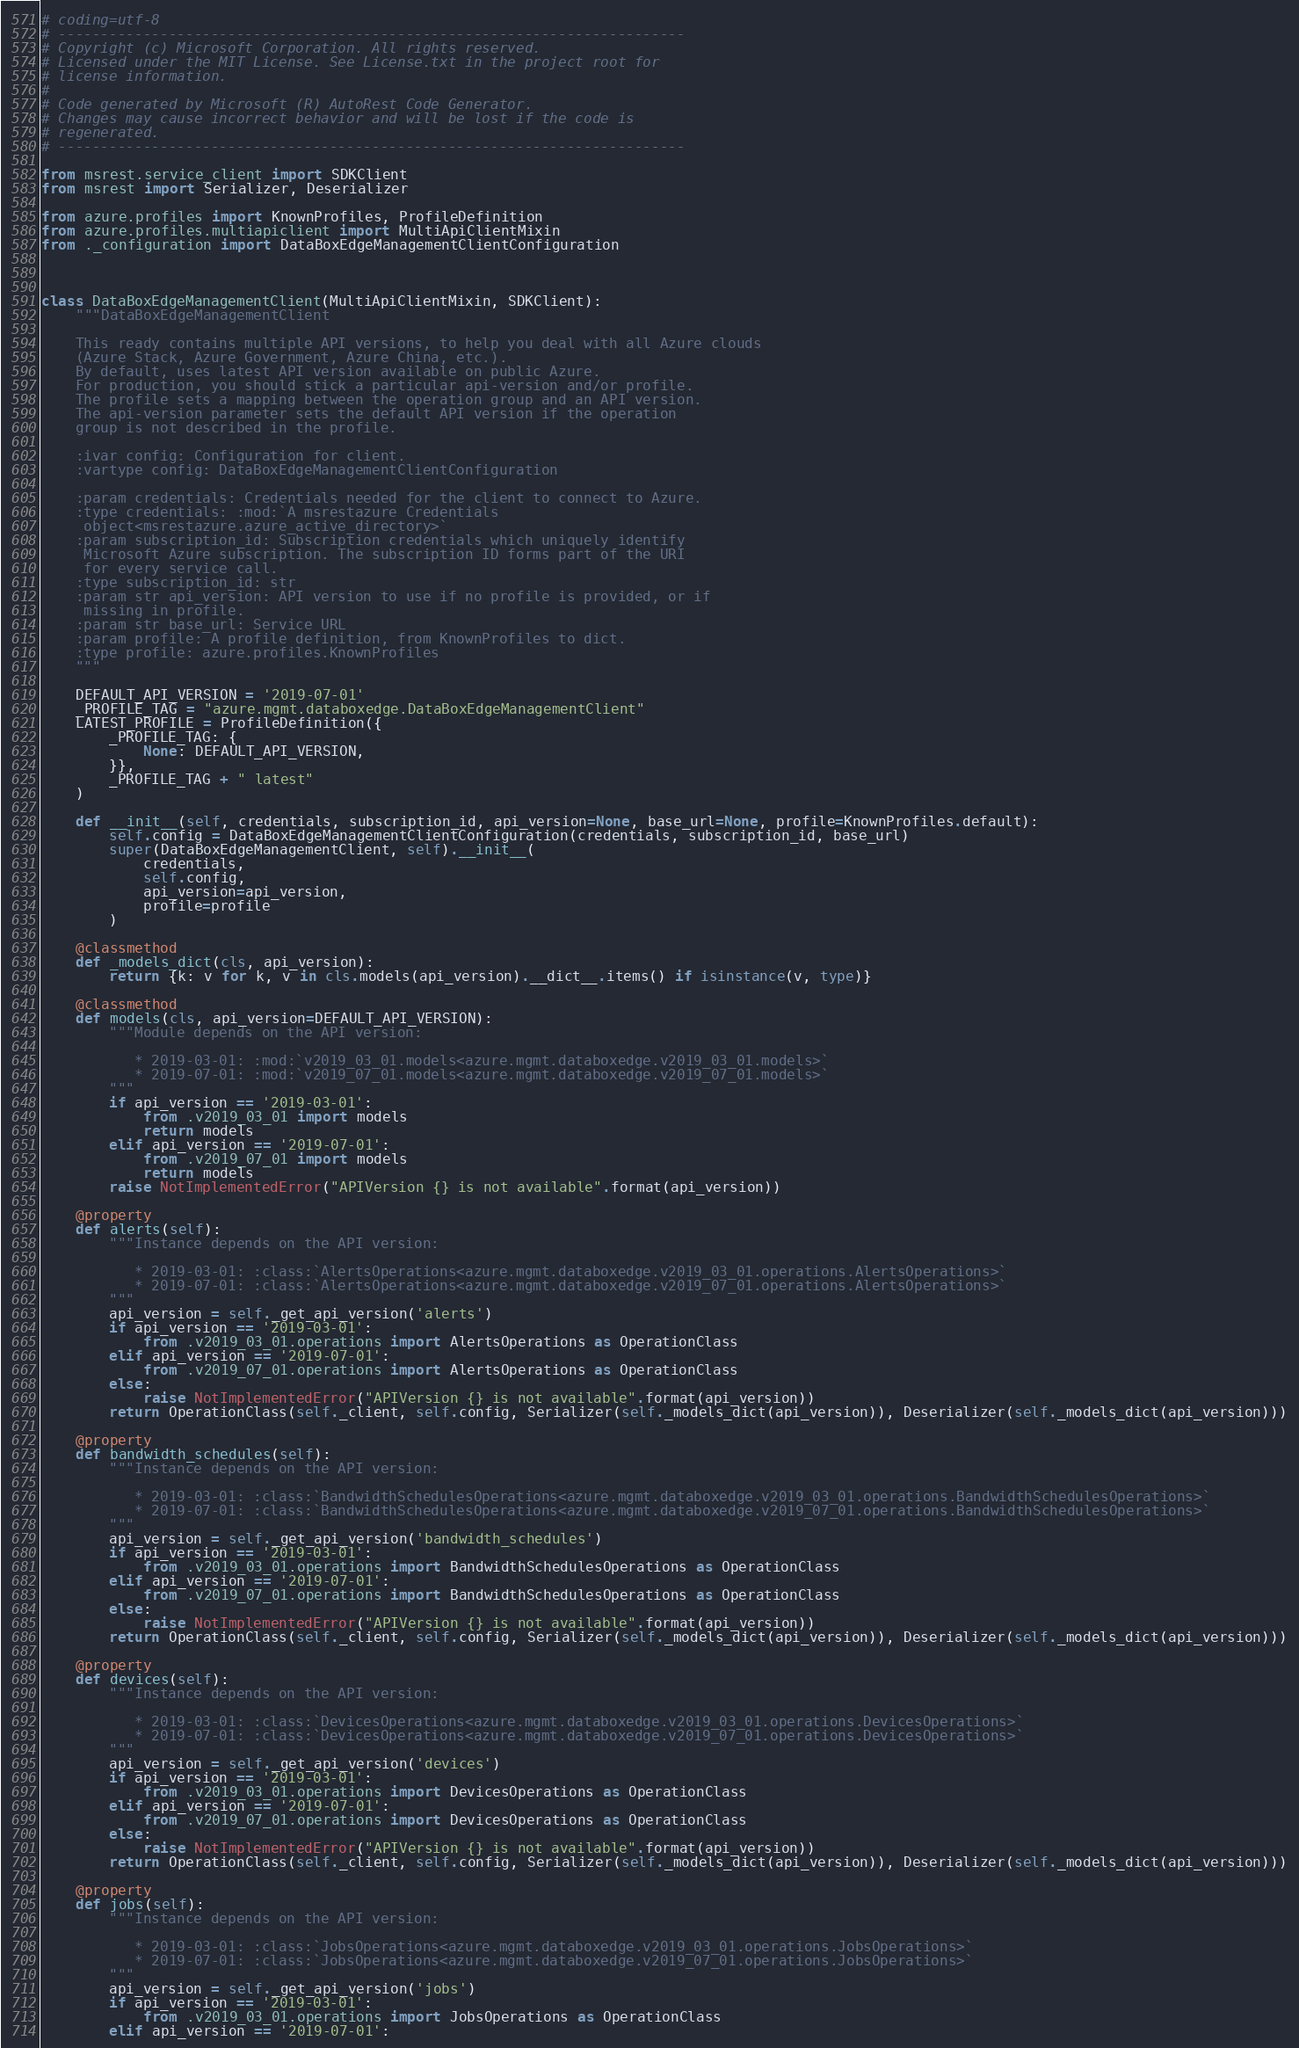<code> <loc_0><loc_0><loc_500><loc_500><_Python_># coding=utf-8
# --------------------------------------------------------------------------
# Copyright (c) Microsoft Corporation. All rights reserved.
# Licensed under the MIT License. See License.txt in the project root for
# license information.
#
# Code generated by Microsoft (R) AutoRest Code Generator.
# Changes may cause incorrect behavior and will be lost if the code is
# regenerated.
# --------------------------------------------------------------------------

from msrest.service_client import SDKClient
from msrest import Serializer, Deserializer

from azure.profiles import KnownProfiles, ProfileDefinition
from azure.profiles.multiapiclient import MultiApiClientMixin
from ._configuration import DataBoxEdgeManagementClientConfiguration



class DataBoxEdgeManagementClient(MultiApiClientMixin, SDKClient):
    """DataBoxEdgeManagementClient

    This ready contains multiple API versions, to help you deal with all Azure clouds
    (Azure Stack, Azure Government, Azure China, etc.).
    By default, uses latest API version available on public Azure.
    For production, you should stick a particular api-version and/or profile.
    The profile sets a mapping between the operation group and an API version.
    The api-version parameter sets the default API version if the operation
    group is not described in the profile.

    :ivar config: Configuration for client.
    :vartype config: DataBoxEdgeManagementClientConfiguration

    :param credentials: Credentials needed for the client to connect to Azure.
    :type credentials: :mod:`A msrestazure Credentials
     object<msrestazure.azure_active_directory>`
    :param subscription_id: Subscription credentials which uniquely identify
     Microsoft Azure subscription. The subscription ID forms part of the URI
     for every service call.
    :type subscription_id: str
    :param str api_version: API version to use if no profile is provided, or if
     missing in profile.
    :param str base_url: Service URL
    :param profile: A profile definition, from KnownProfiles to dict.
    :type profile: azure.profiles.KnownProfiles
    """

    DEFAULT_API_VERSION = '2019-07-01'
    _PROFILE_TAG = "azure.mgmt.databoxedge.DataBoxEdgeManagementClient"
    LATEST_PROFILE = ProfileDefinition({
        _PROFILE_TAG: {
            None: DEFAULT_API_VERSION,
        }},
        _PROFILE_TAG + " latest"
    )

    def __init__(self, credentials, subscription_id, api_version=None, base_url=None, profile=KnownProfiles.default):
        self.config = DataBoxEdgeManagementClientConfiguration(credentials, subscription_id, base_url)
        super(DataBoxEdgeManagementClient, self).__init__(
            credentials,
            self.config,
            api_version=api_version,
            profile=profile
        )

    @classmethod
    def _models_dict(cls, api_version):
        return {k: v for k, v in cls.models(api_version).__dict__.items() if isinstance(v, type)}

    @classmethod
    def models(cls, api_version=DEFAULT_API_VERSION):
        """Module depends on the API version:

           * 2019-03-01: :mod:`v2019_03_01.models<azure.mgmt.databoxedge.v2019_03_01.models>`
           * 2019-07-01: :mod:`v2019_07_01.models<azure.mgmt.databoxedge.v2019_07_01.models>`
        """
        if api_version == '2019-03-01':
            from .v2019_03_01 import models
            return models
        elif api_version == '2019-07-01':
            from .v2019_07_01 import models
            return models
        raise NotImplementedError("APIVersion {} is not available".format(api_version))

    @property
    def alerts(self):
        """Instance depends on the API version:

           * 2019-03-01: :class:`AlertsOperations<azure.mgmt.databoxedge.v2019_03_01.operations.AlertsOperations>`
           * 2019-07-01: :class:`AlertsOperations<azure.mgmt.databoxedge.v2019_07_01.operations.AlertsOperations>`
        """
        api_version = self._get_api_version('alerts')
        if api_version == '2019-03-01':
            from .v2019_03_01.operations import AlertsOperations as OperationClass
        elif api_version == '2019-07-01':
            from .v2019_07_01.operations import AlertsOperations as OperationClass
        else:
            raise NotImplementedError("APIVersion {} is not available".format(api_version))
        return OperationClass(self._client, self.config, Serializer(self._models_dict(api_version)), Deserializer(self._models_dict(api_version)))

    @property
    def bandwidth_schedules(self):
        """Instance depends on the API version:

           * 2019-03-01: :class:`BandwidthSchedulesOperations<azure.mgmt.databoxedge.v2019_03_01.operations.BandwidthSchedulesOperations>`
           * 2019-07-01: :class:`BandwidthSchedulesOperations<azure.mgmt.databoxedge.v2019_07_01.operations.BandwidthSchedulesOperations>`
        """
        api_version = self._get_api_version('bandwidth_schedules')
        if api_version == '2019-03-01':
            from .v2019_03_01.operations import BandwidthSchedulesOperations as OperationClass
        elif api_version == '2019-07-01':
            from .v2019_07_01.operations import BandwidthSchedulesOperations as OperationClass
        else:
            raise NotImplementedError("APIVersion {} is not available".format(api_version))
        return OperationClass(self._client, self.config, Serializer(self._models_dict(api_version)), Deserializer(self._models_dict(api_version)))

    @property
    def devices(self):
        """Instance depends on the API version:

           * 2019-03-01: :class:`DevicesOperations<azure.mgmt.databoxedge.v2019_03_01.operations.DevicesOperations>`
           * 2019-07-01: :class:`DevicesOperations<azure.mgmt.databoxedge.v2019_07_01.operations.DevicesOperations>`
        """
        api_version = self._get_api_version('devices')
        if api_version == '2019-03-01':
            from .v2019_03_01.operations import DevicesOperations as OperationClass
        elif api_version == '2019-07-01':
            from .v2019_07_01.operations import DevicesOperations as OperationClass
        else:
            raise NotImplementedError("APIVersion {} is not available".format(api_version))
        return OperationClass(self._client, self.config, Serializer(self._models_dict(api_version)), Deserializer(self._models_dict(api_version)))

    @property
    def jobs(self):
        """Instance depends on the API version:

           * 2019-03-01: :class:`JobsOperations<azure.mgmt.databoxedge.v2019_03_01.operations.JobsOperations>`
           * 2019-07-01: :class:`JobsOperations<azure.mgmt.databoxedge.v2019_07_01.operations.JobsOperations>`
        """
        api_version = self._get_api_version('jobs')
        if api_version == '2019-03-01':
            from .v2019_03_01.operations import JobsOperations as OperationClass
        elif api_version == '2019-07-01':</code> 